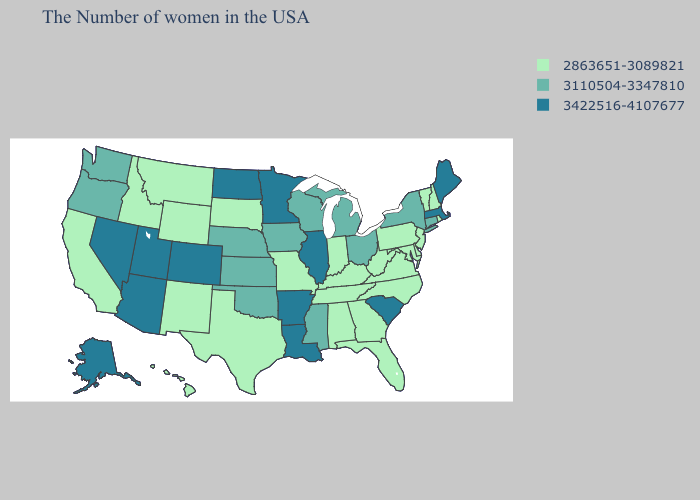What is the value of Idaho?
Give a very brief answer. 2863651-3089821. Does Maine have the lowest value in the Northeast?
Concise answer only. No. Among the states that border Georgia , which have the highest value?
Write a very short answer. South Carolina. Among the states that border Rhode Island , which have the lowest value?
Quick response, please. Connecticut. Name the states that have a value in the range 2863651-3089821?
Give a very brief answer. Rhode Island, New Hampshire, Vermont, New Jersey, Delaware, Maryland, Pennsylvania, Virginia, North Carolina, West Virginia, Florida, Georgia, Kentucky, Indiana, Alabama, Tennessee, Missouri, Texas, South Dakota, Wyoming, New Mexico, Montana, Idaho, California, Hawaii. What is the value of South Dakota?
Short answer required. 2863651-3089821. What is the lowest value in the USA?
Short answer required. 2863651-3089821. Name the states that have a value in the range 3422516-4107677?
Short answer required. Maine, Massachusetts, South Carolina, Illinois, Louisiana, Arkansas, Minnesota, North Dakota, Colorado, Utah, Arizona, Nevada, Alaska. Name the states that have a value in the range 3422516-4107677?
Be succinct. Maine, Massachusetts, South Carolina, Illinois, Louisiana, Arkansas, Minnesota, North Dakota, Colorado, Utah, Arizona, Nevada, Alaska. Is the legend a continuous bar?
Quick response, please. No. What is the value of New Mexico?
Quick response, please. 2863651-3089821. Does Arizona have the same value as Alaska?
Short answer required. Yes. Which states have the lowest value in the West?
Concise answer only. Wyoming, New Mexico, Montana, Idaho, California, Hawaii. Does the first symbol in the legend represent the smallest category?
Be succinct. Yes. 